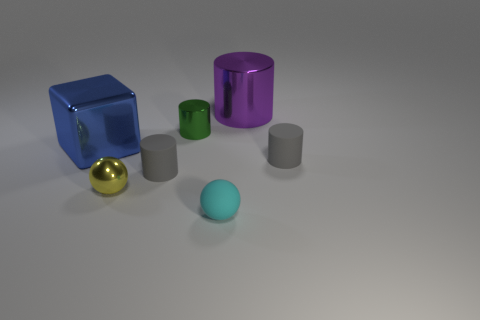Subtract all cyan blocks. Subtract all red spheres. How many blocks are left? 1 Add 1 big blue things. How many objects exist? 8 Subtract all spheres. How many objects are left? 5 Add 4 gray objects. How many gray objects exist? 6 Subtract 0 gray spheres. How many objects are left? 7 Subtract all tiny matte spheres. Subtract all yellow metallic things. How many objects are left? 5 Add 4 big cylinders. How many big cylinders are left? 5 